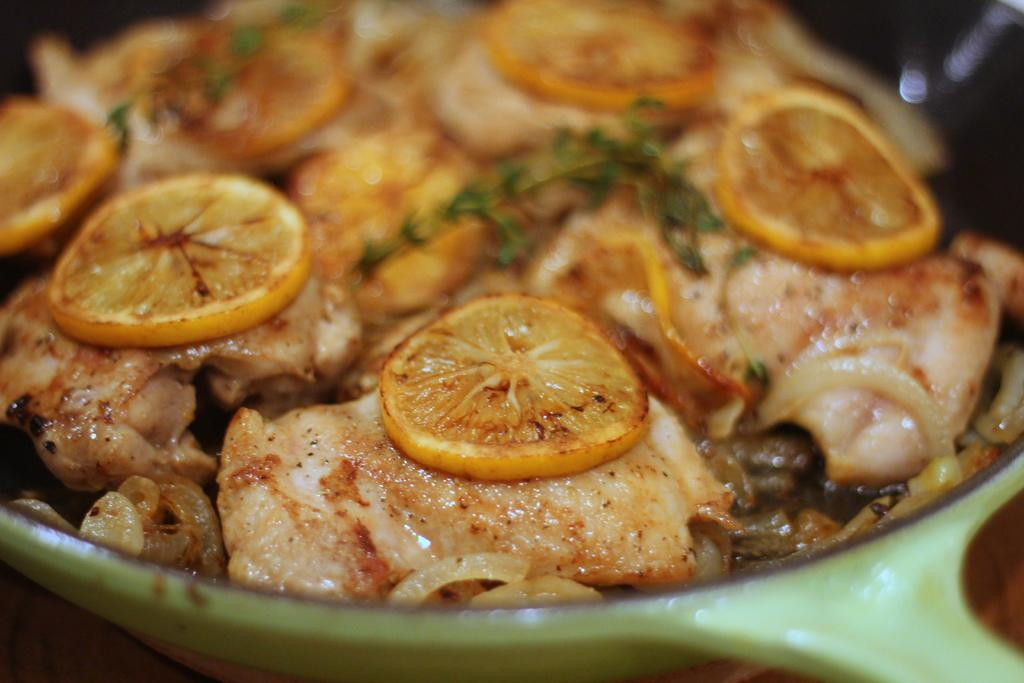What is in the bowl that is visible in the image? There is food in a bowl in the image. What type of truck is parked on the page during the holiday in the image? There is no truck, page, or holiday present in the image; it only features a bowl of food. 